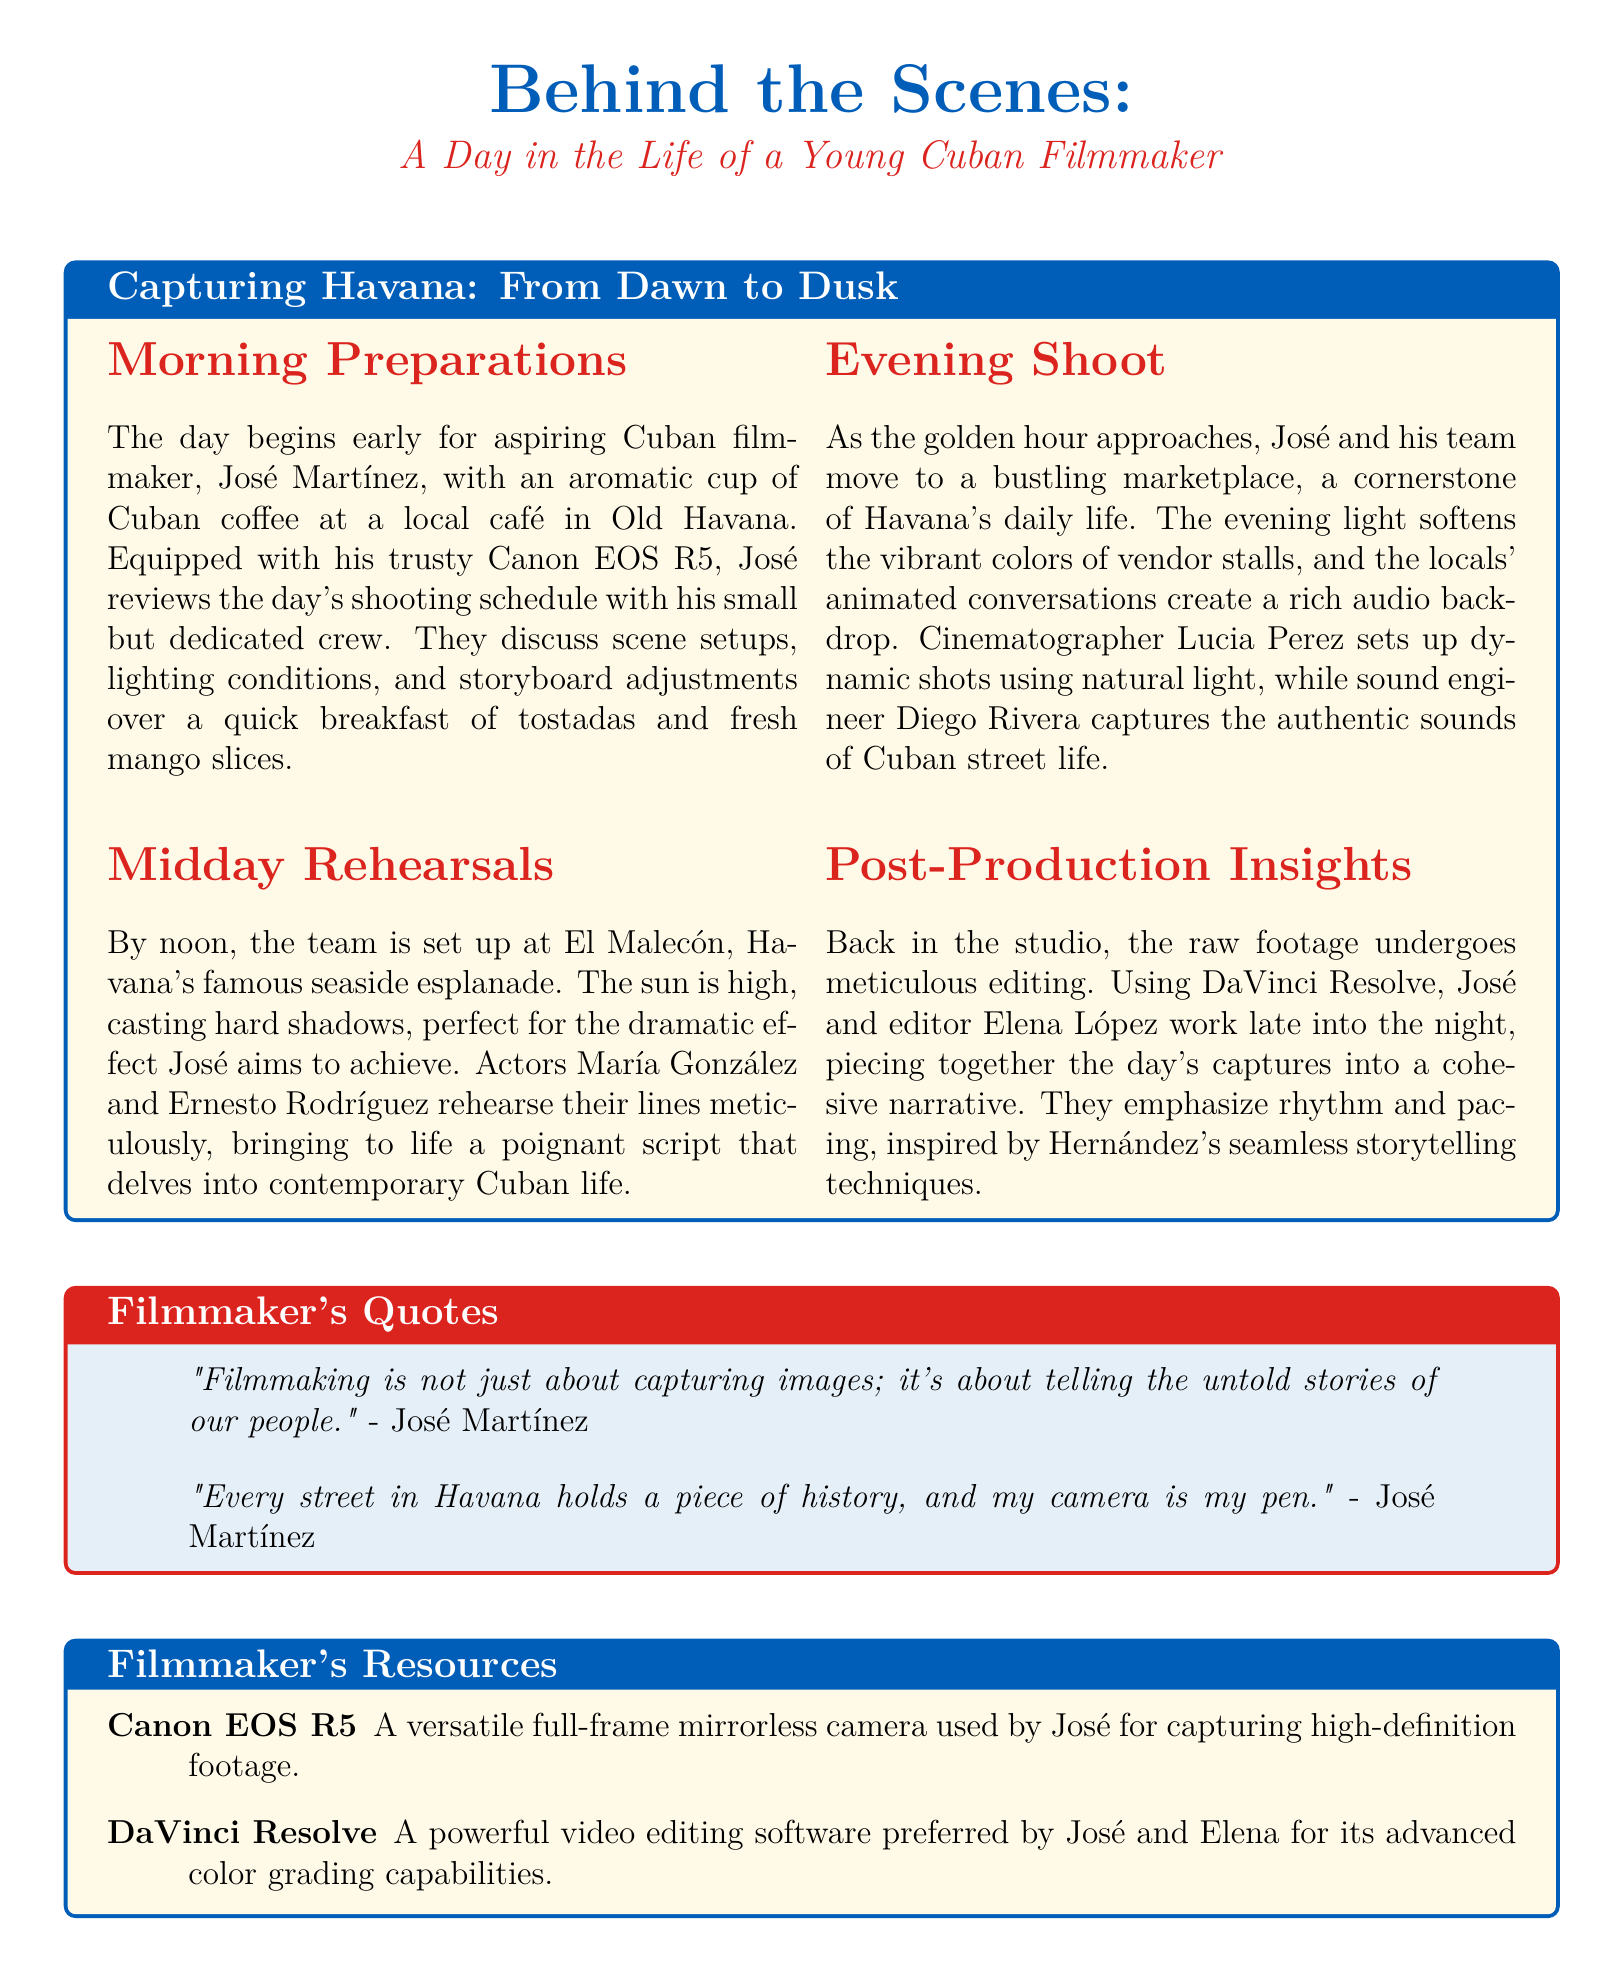what is the filmmaker's name? The document mentions José Martínez as the aspiring Cuban filmmaker.
Answer: José Martínez where does José begin his day? According to the document, José starts his day at a local café in Old Havana.
Answer: local café in Old Havana what camera does José use? The document specifies that José uses a Canon EOS R5 for filming.
Answer: Canon EOS R5 what time of day does the evening shoot take place? The evening shoot is mentioned to occur as the golden hour approaches.
Answer: golden hour who is the editor that works with José in post-production? The document states that Elena López is the editor who works with José.
Answer: Elena López what software do José and Elena use for editing? The document reveals that DaVinci Resolve is the software they use for editing.
Answer: DaVinci Resolve which location serves as the setting for midday rehearsals? It is indicated that the midday rehearsals take place at El Malecón.
Answer: El Malecón what theme does José's script explore? The document mentions that José's script delves into contemporary Cuban life.
Answer: contemporary Cuban life how does José describe his filmmaking philosophy in one of his quotes? The document includes José's view that filmmaking is about telling untold stories of our people.
Answer: telling the untold stories of our people 